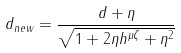Convert formula to latex. <formula><loc_0><loc_0><loc_500><loc_500>d _ { n e w } = \frac { d + \eta } { \sqrt { 1 + 2 \eta h ^ { \mu \zeta } + \eta ^ { 2 } } }</formula> 